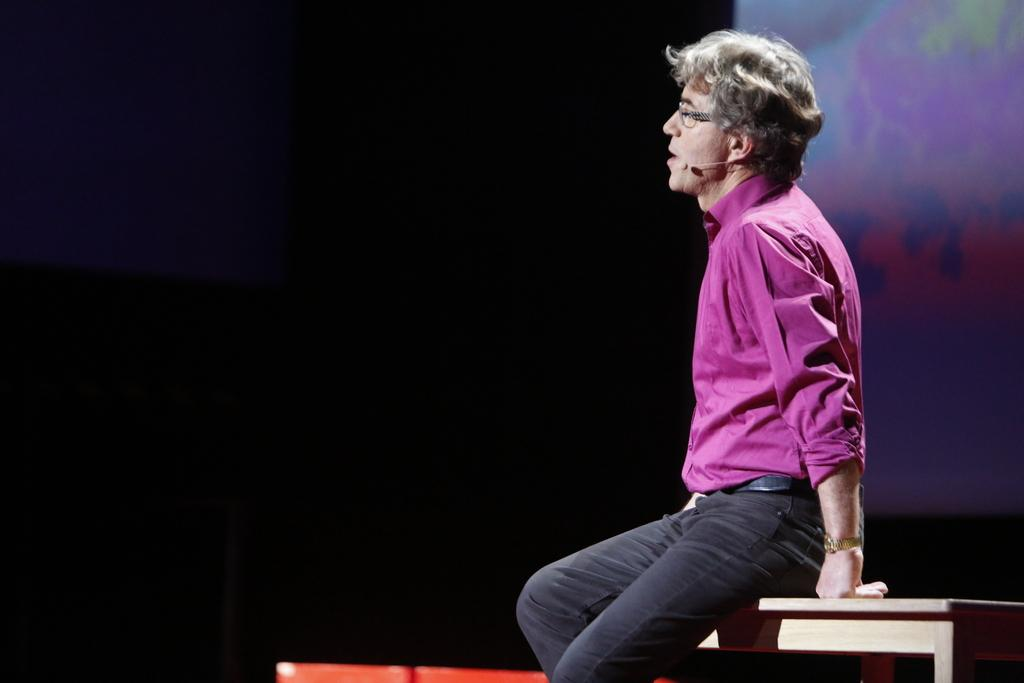What is the man in the image wearing? The man is wearing a pink shirt and black jeans. What is the man doing in the image? The man is sitting on a table and talking on a microphone. What can be seen on the right side of the image? There is an abstract wall on the right side of the image. How is the area in front of the man lit? The area in front of the man is dark. What scent can be detected coming from the man's pink shirt in the image? There is no information about the scent of the man's pink shirt in the image. 